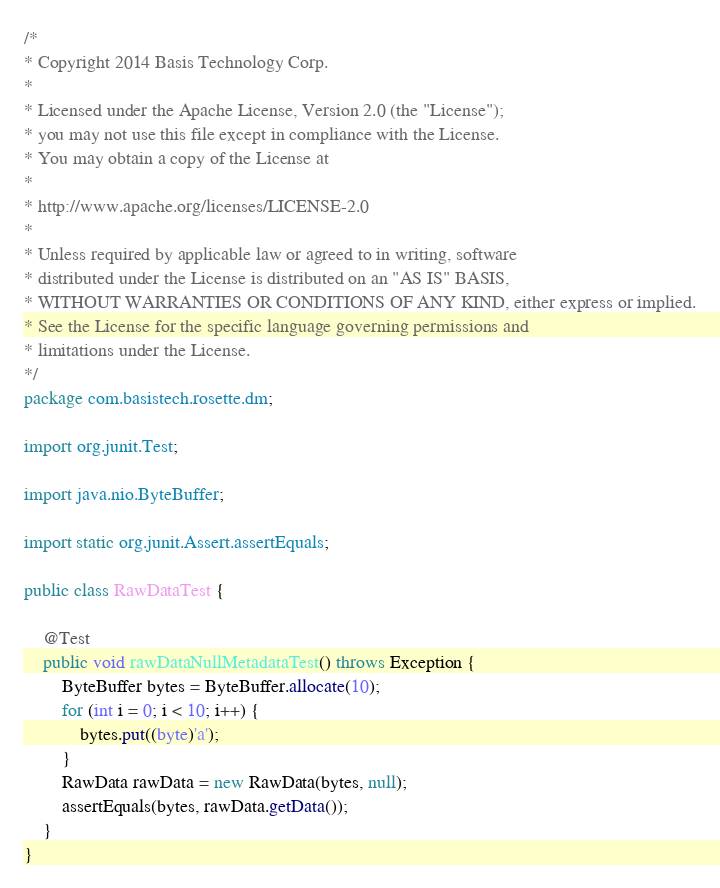<code> <loc_0><loc_0><loc_500><loc_500><_Java_>/*
* Copyright 2014 Basis Technology Corp.
*
* Licensed under the Apache License, Version 2.0 (the "License");
* you may not use this file except in compliance with the License.
* You may obtain a copy of the License at
*
* http://www.apache.org/licenses/LICENSE-2.0
*
* Unless required by applicable law or agreed to in writing, software
* distributed under the License is distributed on an "AS IS" BASIS,
* WITHOUT WARRANTIES OR CONDITIONS OF ANY KIND, either express or implied.
* See the License for the specific language governing permissions and
* limitations under the License.
*/
package com.basistech.rosette.dm;

import org.junit.Test;

import java.nio.ByteBuffer;

import static org.junit.Assert.assertEquals;

public class RawDataTest {

    @Test
    public void rawDataNullMetadataTest() throws Exception {
        ByteBuffer bytes = ByteBuffer.allocate(10);
        for (int i = 0; i < 10; i++) {
            bytes.put((byte)'a');
        }
        RawData rawData = new RawData(bytes, null);
        assertEquals(bytes, rawData.getData());
    }
}
</code> 